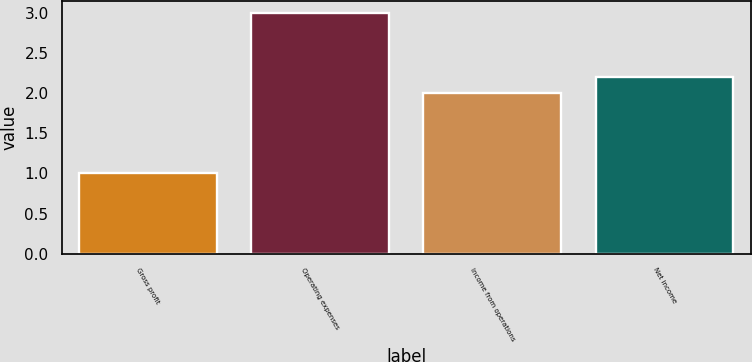Convert chart. <chart><loc_0><loc_0><loc_500><loc_500><bar_chart><fcel>Gross profit<fcel>Operating expenses<fcel>Income from operations<fcel>Net income<nl><fcel>1<fcel>3<fcel>2<fcel>2.2<nl></chart> 